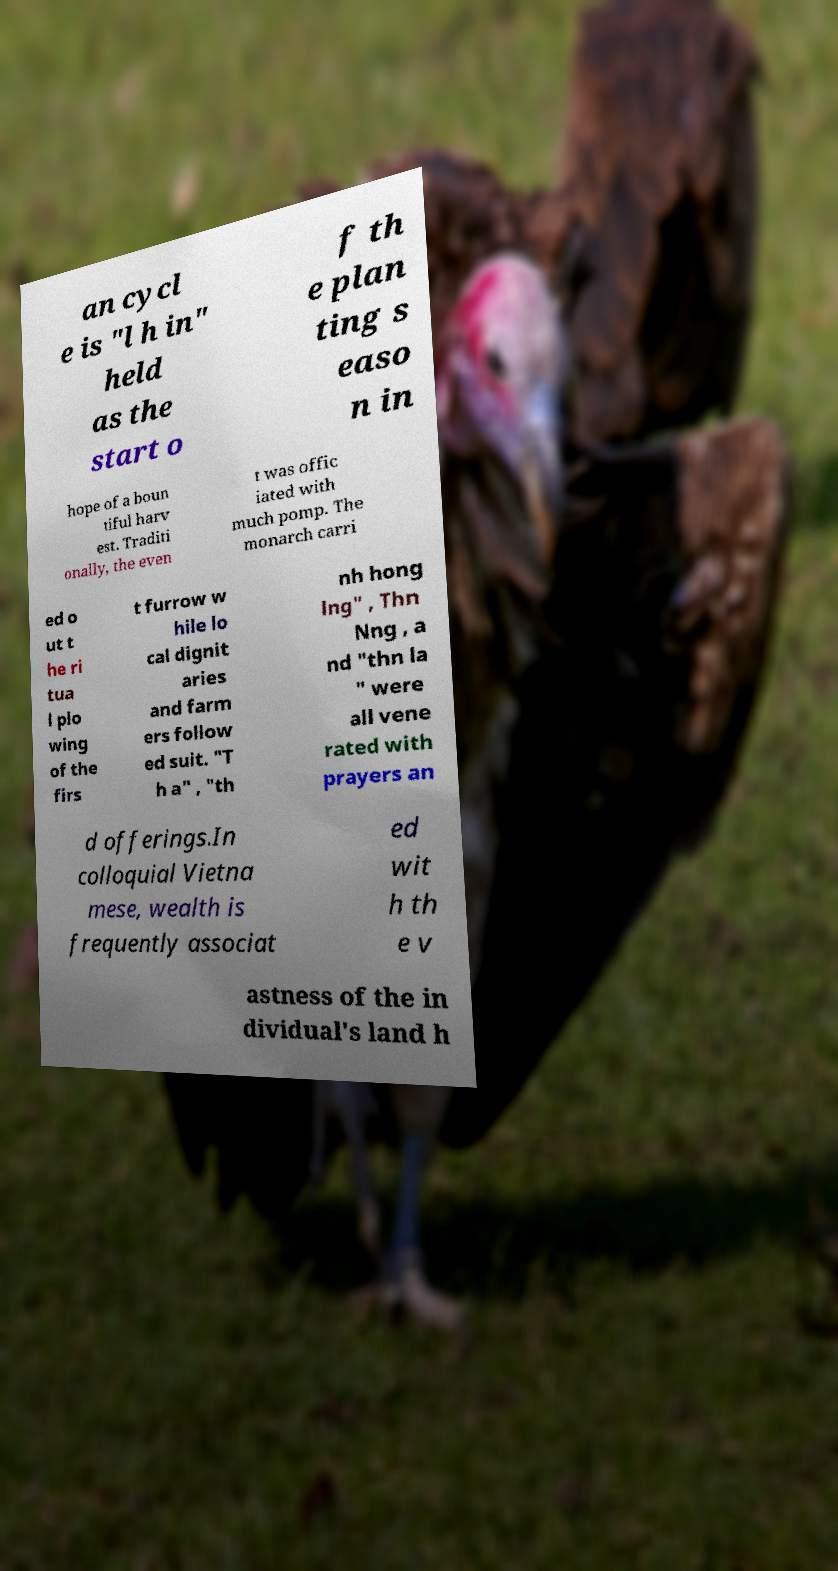Please read and relay the text visible in this image. What does it say? an cycl e is "l h in" held as the start o f th e plan ting s easo n in hope of a boun tiful harv est. Traditi onally, the even t was offic iated with much pomp. The monarch carri ed o ut t he ri tua l plo wing of the firs t furrow w hile lo cal dignit aries and farm ers follow ed suit. "T h a" , "th nh hong lng" , Thn Nng , a nd "thn la " were all vene rated with prayers an d offerings.In colloquial Vietna mese, wealth is frequently associat ed wit h th e v astness of the in dividual's land h 